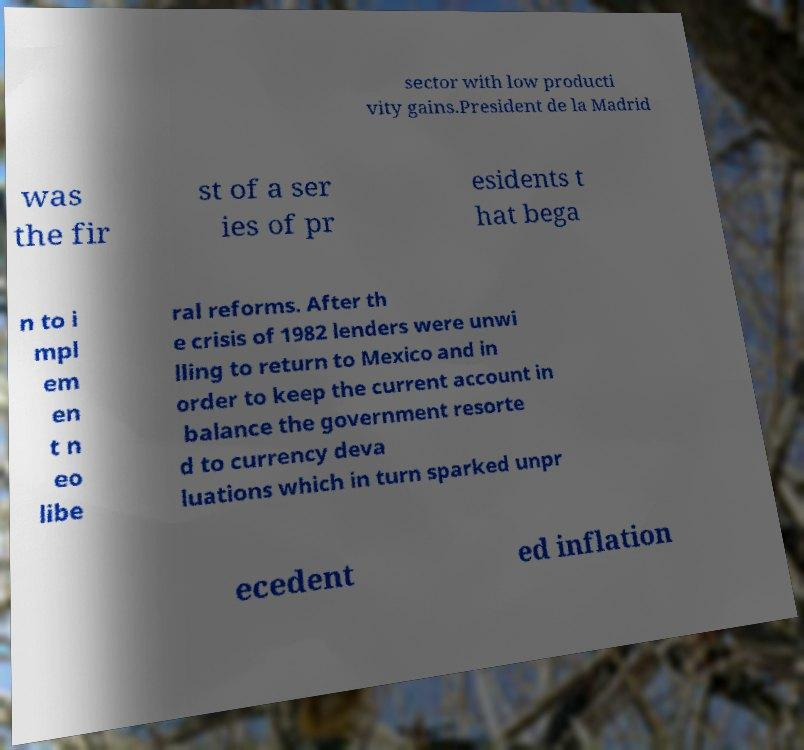There's text embedded in this image that I need extracted. Can you transcribe it verbatim? sector with low producti vity gains.President de la Madrid was the fir st of a ser ies of pr esidents t hat bega n to i mpl em en t n eo libe ral reforms. After th e crisis of 1982 lenders were unwi lling to return to Mexico and in order to keep the current account in balance the government resorte d to currency deva luations which in turn sparked unpr ecedent ed inflation 